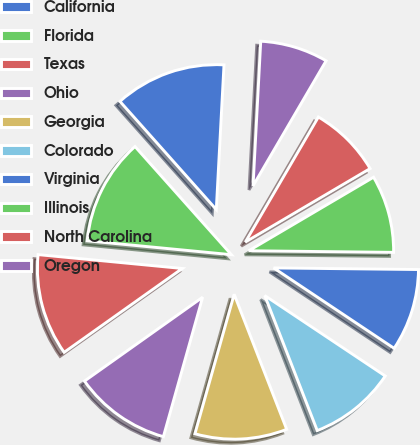Convert chart. <chart><loc_0><loc_0><loc_500><loc_500><pie_chart><fcel>California<fcel>Florida<fcel>Texas<fcel>Ohio<fcel>Georgia<fcel>Colorado<fcel>Virginia<fcel>Illinois<fcel>North Carolina<fcel>Oregon<nl><fcel>12.43%<fcel>11.89%<fcel>11.35%<fcel>10.81%<fcel>10.27%<fcel>9.73%<fcel>9.19%<fcel>8.65%<fcel>8.11%<fcel>7.57%<nl></chart> 